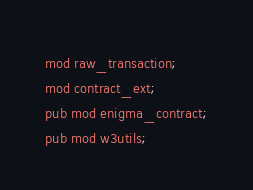Convert code to text. <code><loc_0><loc_0><loc_500><loc_500><_Rust_>mod raw_transaction;
mod contract_ext;
pub mod enigma_contract;
pub mod w3utils;
</code> 